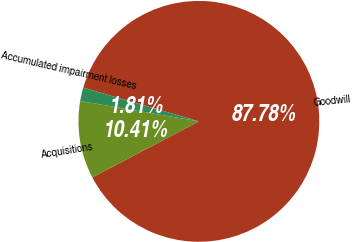<chart> <loc_0><loc_0><loc_500><loc_500><pie_chart><fcel>Goodwill<fcel>Acquisitions<fcel>Accumulated impairment losses<nl><fcel>87.77%<fcel>10.41%<fcel>1.81%<nl></chart> 